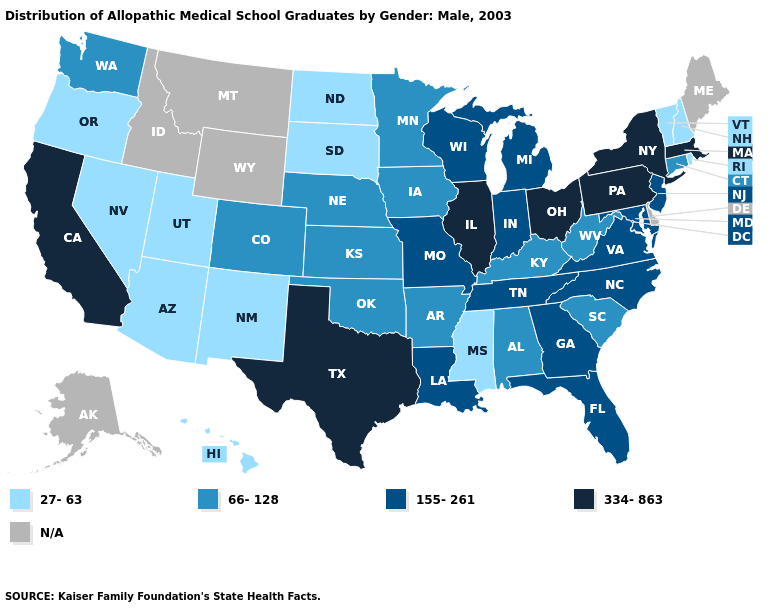What is the highest value in the Northeast ?
Write a very short answer. 334-863. What is the highest value in states that border Maine?
Short answer required. 27-63. What is the value of Kansas?
Answer briefly. 66-128. Name the states that have a value in the range 334-863?
Concise answer only. California, Illinois, Massachusetts, New York, Ohio, Pennsylvania, Texas. What is the value of Massachusetts?
Write a very short answer. 334-863. What is the value of Texas?
Write a very short answer. 334-863. What is the value of West Virginia?
Write a very short answer. 66-128. Which states have the highest value in the USA?
Write a very short answer. California, Illinois, Massachusetts, New York, Ohio, Pennsylvania, Texas. Does the map have missing data?
Be succinct. Yes. Name the states that have a value in the range N/A?
Short answer required. Alaska, Delaware, Idaho, Maine, Montana, Wyoming. What is the value of South Carolina?
Keep it brief. 66-128. Among the states that border Wisconsin , which have the highest value?
Answer briefly. Illinois. What is the highest value in the West ?
Quick response, please. 334-863. Which states have the lowest value in the West?
Answer briefly. Arizona, Hawaii, Nevada, New Mexico, Oregon, Utah. Among the states that border Wyoming , which have the highest value?
Give a very brief answer. Colorado, Nebraska. 